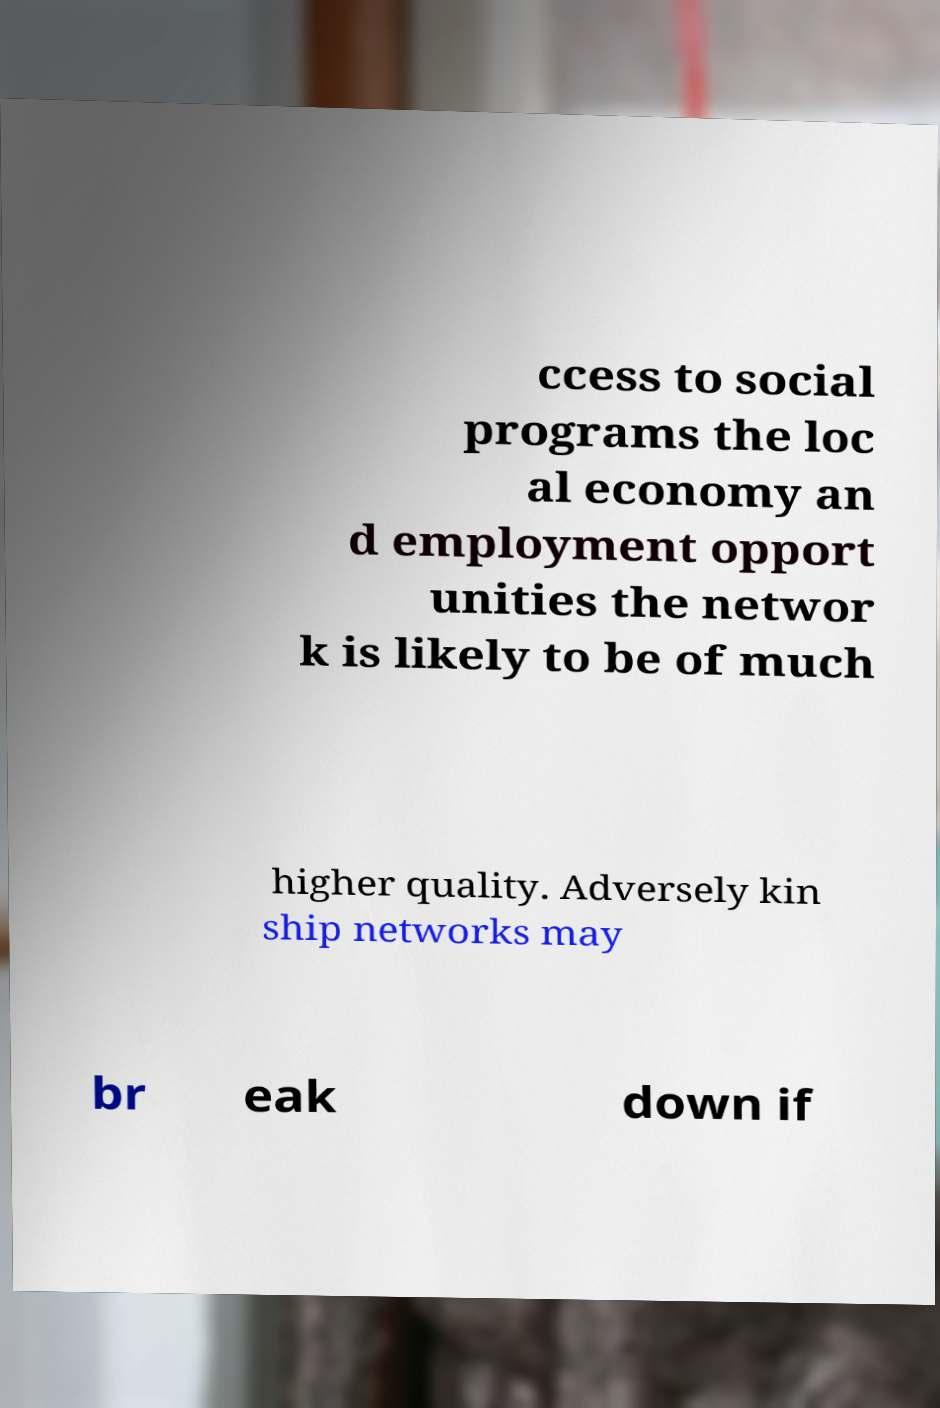Could you assist in decoding the text presented in this image and type it out clearly? ccess to social programs the loc al economy an d employment opport unities the networ k is likely to be of much higher quality. Adversely kin ship networks may br eak down if 